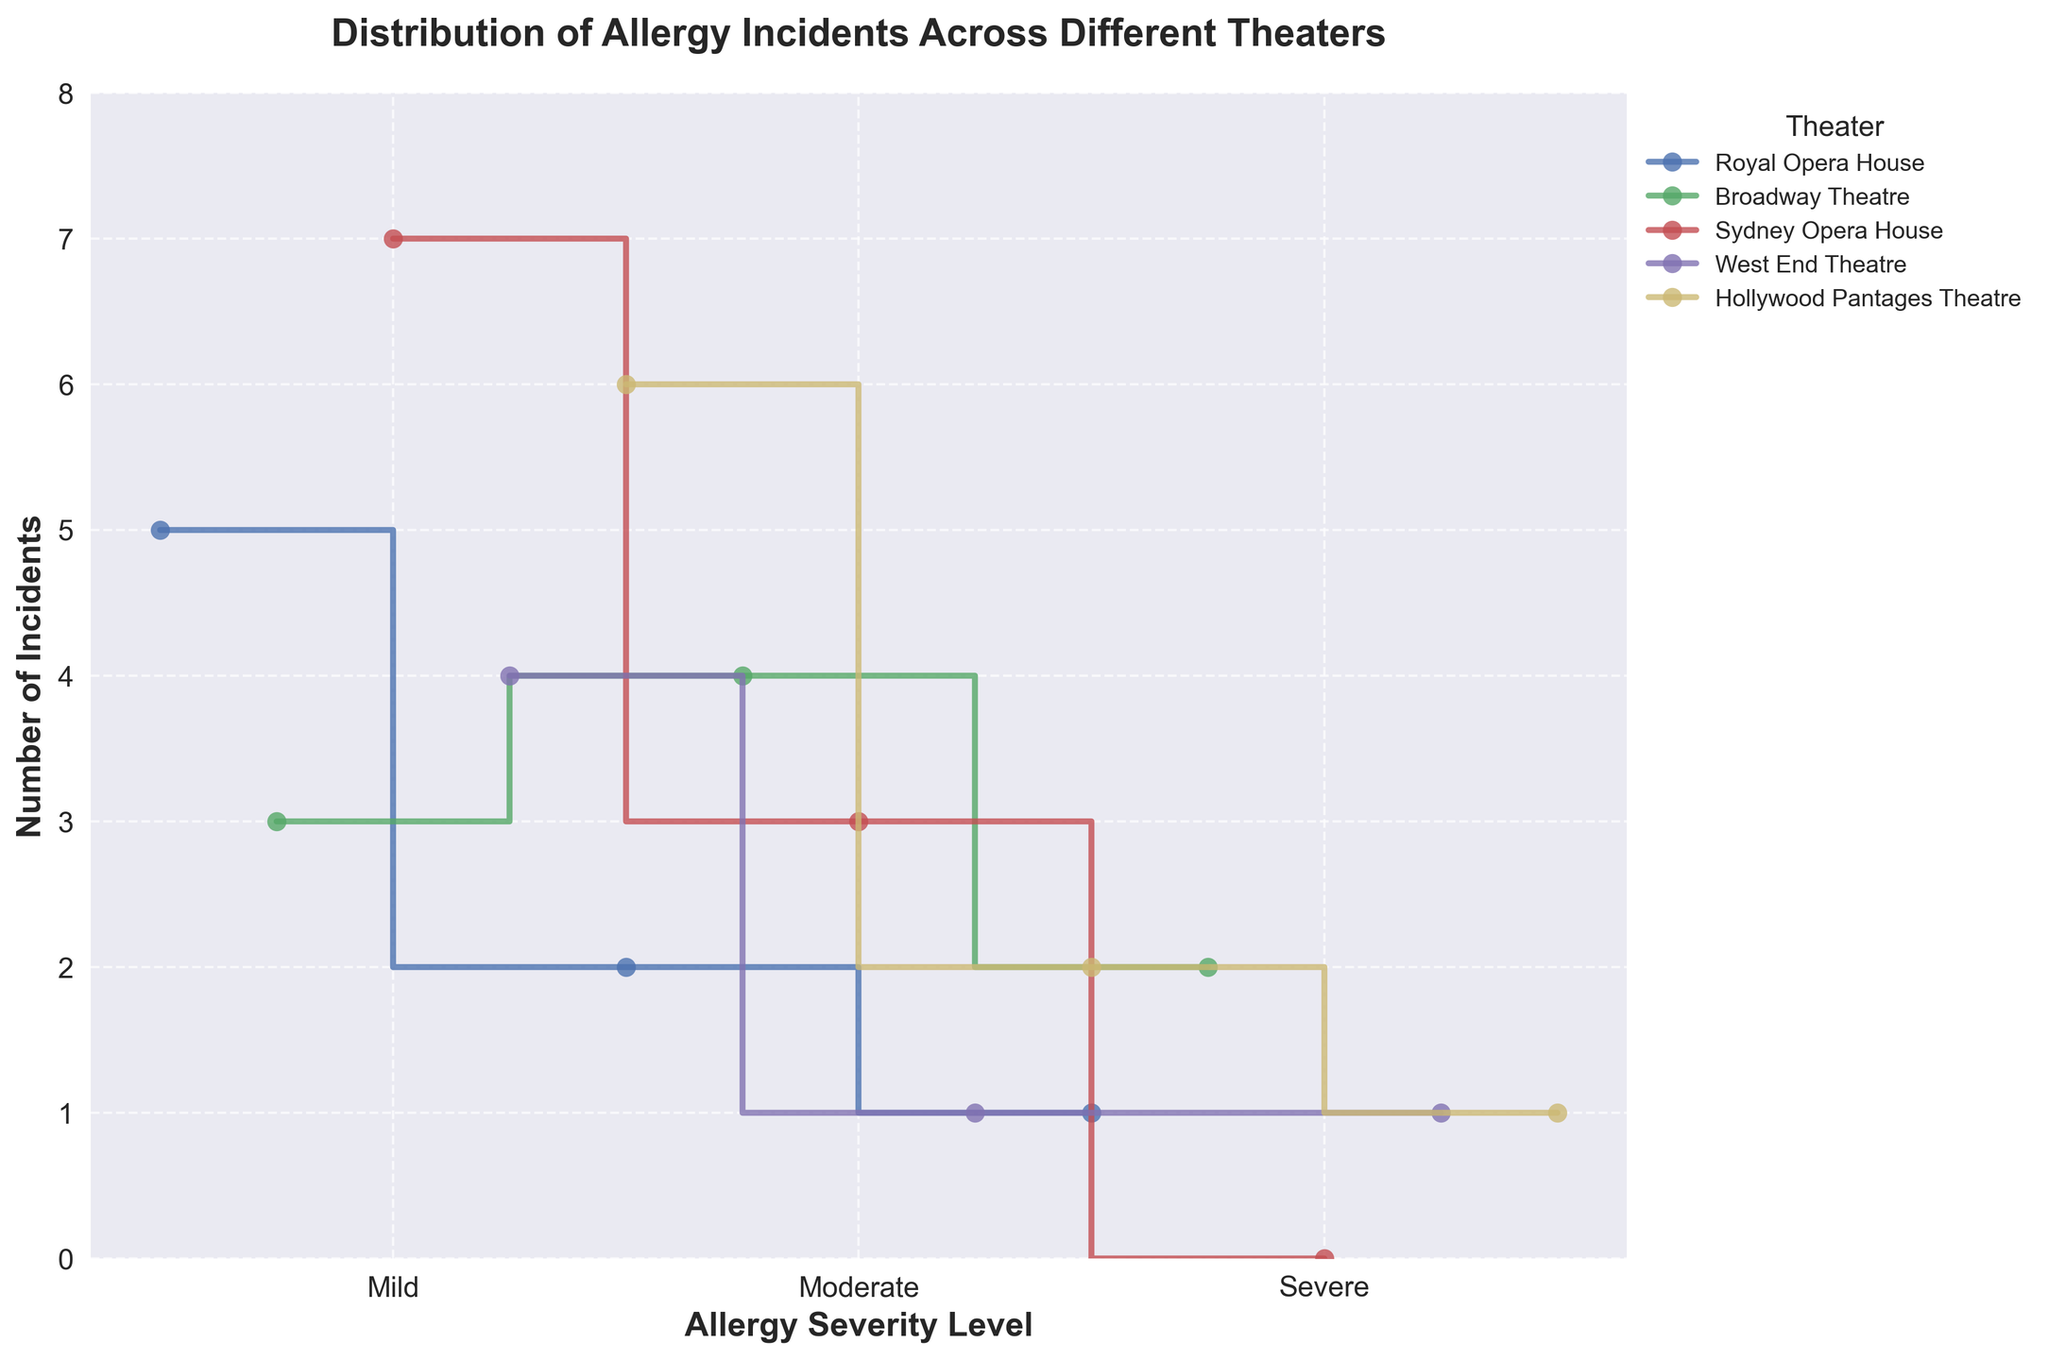What's the title of the figure? The title is usually located at the top of the figure.
Answer: Distribution of Allergy Incidents Across Different Theaters and Their Severity Levels Which severity level has the highest number of incidents in the Sydney Opera House? Looking at the Sydney Opera House line, the severity level that reaches the highest point on the y-axis indicates the highest number of incidents.
Answer: Mild How many theaters show incidents for all three severity levels? Observing each theater's line to see if incidents are plotted for Mild, Moderate, and Severe will provide the answer.
Answer: 4 Which theater has the least number of Severe incidents? Comparing the heights of the Severe data points for each theater will show which is the lowest.
Answer: Sydney Opera House What's the total number of Mild incidents across all theaters? Summing the y-values of Mild incidents for all theaters.
Answer: 25 Are there any theaters with more Moderate incidents than Mild incidents? By comparing the y-values of Moderate to Mild incidents for each theater, one can determine this.
Answer: No How does the number of Severe incidents at Broadway Theatre compare to Royal Opera House? Check the heights of Severe incidents for both Broadway Theatre and Royal Opera House.
Answer: Broadway Theatre has more (2 vs. 1) What's the difference in the number of Moderate incidents between Royal Opera House and West End Theatre? Subtracting the number of Moderate incidents in West End Theatre from that in Royal Opera House.
Answer: 1 Which severity level consistently has the lowest number of incidents across all theaters? Observing which severity level tends to have the lowest y-values in multiple theaters will show this.
Answer: Severe How many more Mild incidents are there in Hollywood Pantages Theatre compared to Royal Opera House? Subtract the number of Mild incidents in Royal Opera House from those in Hollywood Pantages Theatre.
Answer: 1 